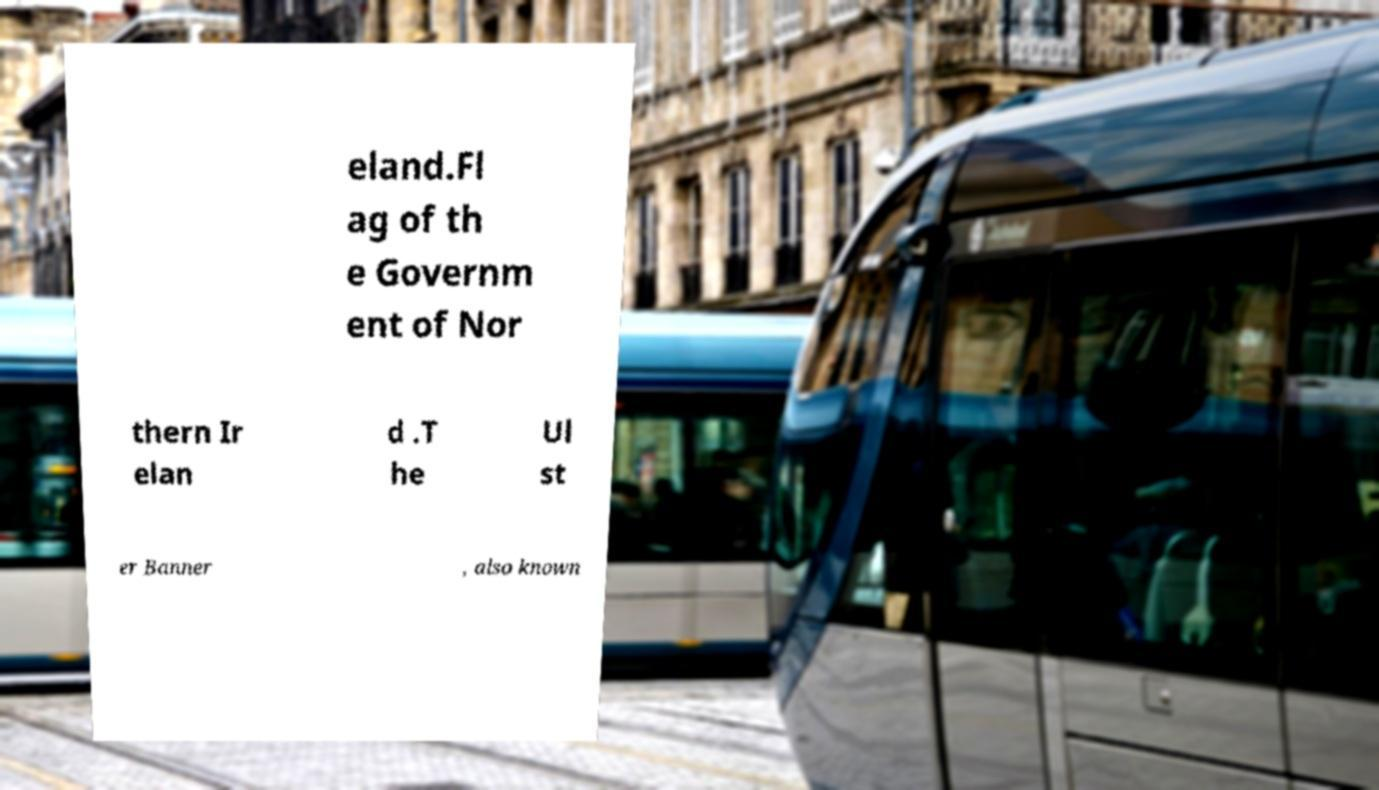There's text embedded in this image that I need extracted. Can you transcribe it verbatim? eland.Fl ag of th e Governm ent of Nor thern Ir elan d .T he Ul st er Banner , also known 